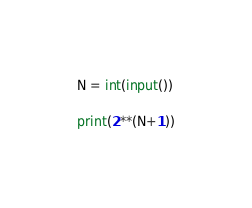Convert code to text. <code><loc_0><loc_0><loc_500><loc_500><_Python_>N = int(input())

print(2**(N+1))</code> 